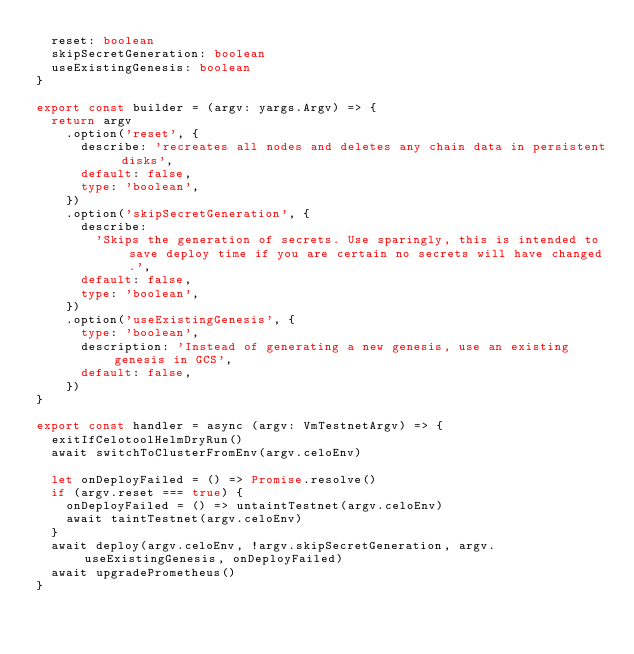Convert code to text. <code><loc_0><loc_0><loc_500><loc_500><_TypeScript_>  reset: boolean
  skipSecretGeneration: boolean
  useExistingGenesis: boolean
}

export const builder = (argv: yargs.Argv) => {
  return argv
    .option('reset', {
      describe: 'recreates all nodes and deletes any chain data in persistent disks',
      default: false,
      type: 'boolean',
    })
    .option('skipSecretGeneration', {
      describe:
        'Skips the generation of secrets. Use sparingly, this is intended to save deploy time if you are certain no secrets will have changed.',
      default: false,
      type: 'boolean',
    })
    .option('useExistingGenesis', {
      type: 'boolean',
      description: 'Instead of generating a new genesis, use an existing genesis in GCS',
      default: false,
    })
}

export const handler = async (argv: VmTestnetArgv) => {
  exitIfCelotoolHelmDryRun()
  await switchToClusterFromEnv(argv.celoEnv)

  let onDeployFailed = () => Promise.resolve()
  if (argv.reset === true) {
    onDeployFailed = () => untaintTestnet(argv.celoEnv)
    await taintTestnet(argv.celoEnv)
  }
  await deploy(argv.celoEnv, !argv.skipSecretGeneration, argv.useExistingGenesis, onDeployFailed)
  await upgradePrometheus()
}
</code> 